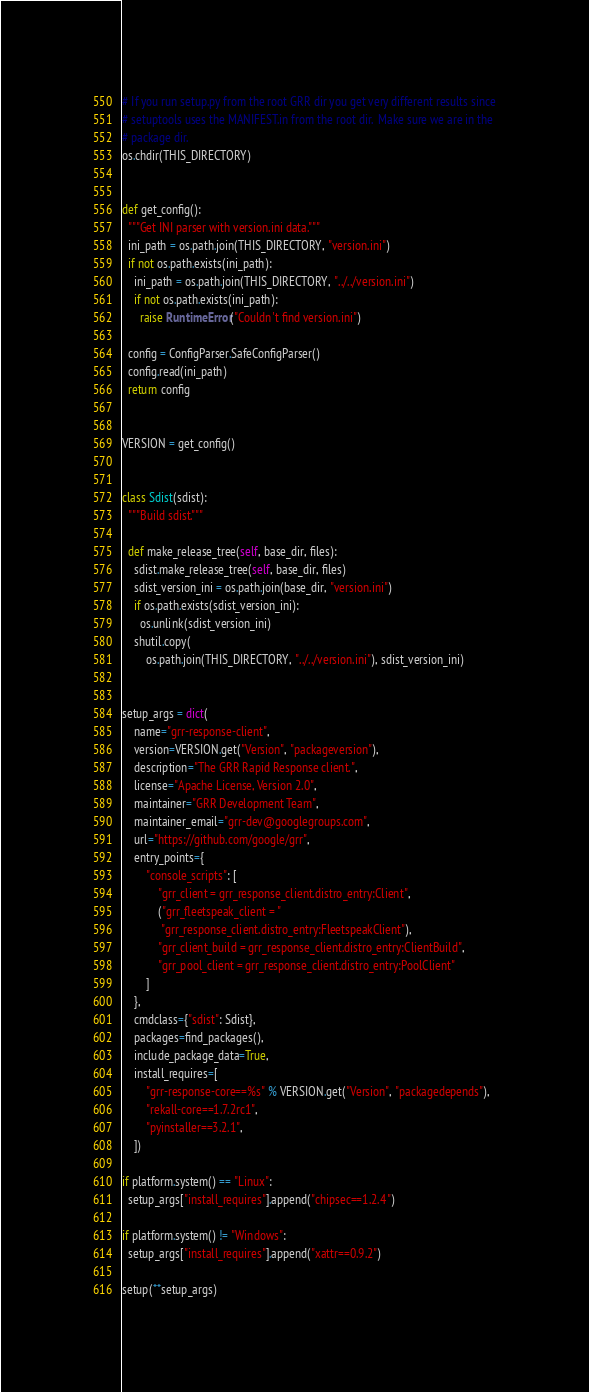Convert code to text. <code><loc_0><loc_0><loc_500><loc_500><_Python_>
# If you run setup.py from the root GRR dir you get very different results since
# setuptools uses the MANIFEST.in from the root dir.  Make sure we are in the
# package dir.
os.chdir(THIS_DIRECTORY)


def get_config():
  """Get INI parser with version.ini data."""
  ini_path = os.path.join(THIS_DIRECTORY, "version.ini")
  if not os.path.exists(ini_path):
    ini_path = os.path.join(THIS_DIRECTORY, "../../version.ini")
    if not os.path.exists(ini_path):
      raise RuntimeError("Couldn't find version.ini")

  config = ConfigParser.SafeConfigParser()
  config.read(ini_path)
  return config


VERSION = get_config()


class Sdist(sdist):
  """Build sdist."""

  def make_release_tree(self, base_dir, files):
    sdist.make_release_tree(self, base_dir, files)
    sdist_version_ini = os.path.join(base_dir, "version.ini")
    if os.path.exists(sdist_version_ini):
      os.unlink(sdist_version_ini)
    shutil.copy(
        os.path.join(THIS_DIRECTORY, "../../version.ini"), sdist_version_ini)


setup_args = dict(
    name="grr-response-client",
    version=VERSION.get("Version", "packageversion"),
    description="The GRR Rapid Response client.",
    license="Apache License, Version 2.0",
    maintainer="GRR Development Team",
    maintainer_email="grr-dev@googlegroups.com",
    url="https://github.com/google/grr",
    entry_points={
        "console_scripts": [
            "grr_client = grr_response_client.distro_entry:Client",
            ("grr_fleetspeak_client = "
             "grr_response_client.distro_entry:FleetspeakClient"),
            "grr_client_build = grr_response_client.distro_entry:ClientBuild",
            "grr_pool_client = grr_response_client.distro_entry:PoolClient"
        ]
    },
    cmdclass={"sdist": Sdist},
    packages=find_packages(),
    include_package_data=True,
    install_requires=[
        "grr-response-core==%s" % VERSION.get("Version", "packagedepends"),
        "rekall-core==1.7.2rc1",
        "pyinstaller==3.2.1",
    ])

if platform.system() == "Linux":
  setup_args["install_requires"].append("chipsec==1.2.4")

if platform.system() != "Windows":
  setup_args["install_requires"].append("xattr==0.9.2")

setup(**setup_args)
</code> 